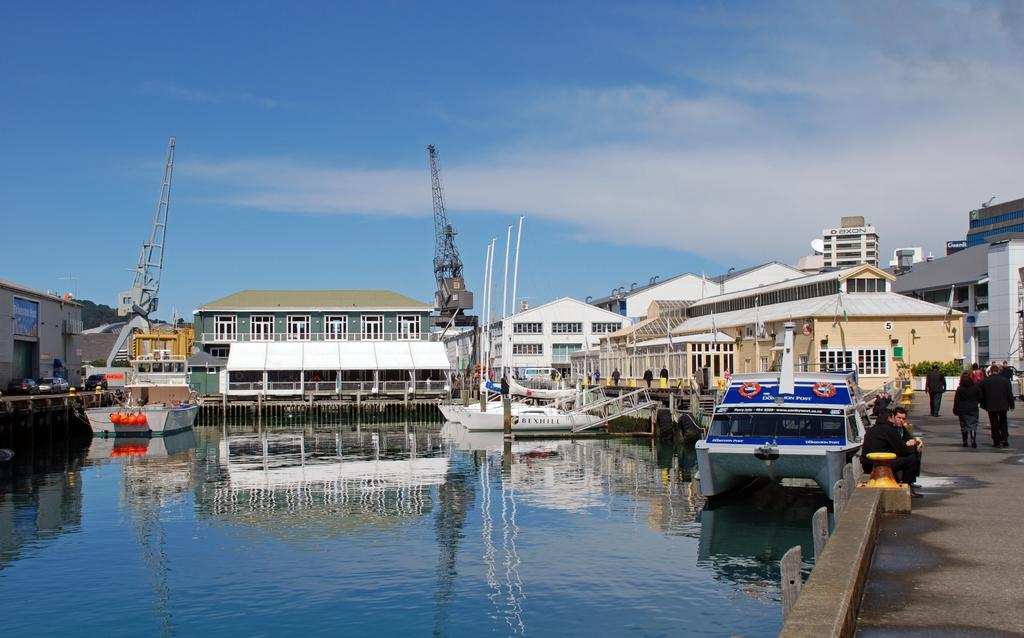What is the condition of the sky in the image? The sky is cloudy in the image. What can be seen on the water in the image? There are boats on the water in the image. What type of structures are visible in the background? There are buildings with windows in the background. Can you identify any living beings in the image? Yes, people are visible in the image. What type of vegetation is present in the image? Plants are present in the image. What type of lipstick is the person wearing in the image? There is no reference to lipstick or any cosmetic products in the image. 